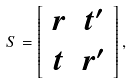<formula> <loc_0><loc_0><loc_500><loc_500>S = \left [ \begin{array} { c c } r & t ^ { \prime } \\ t & r ^ { \prime } \end{array} \right ] ,</formula> 